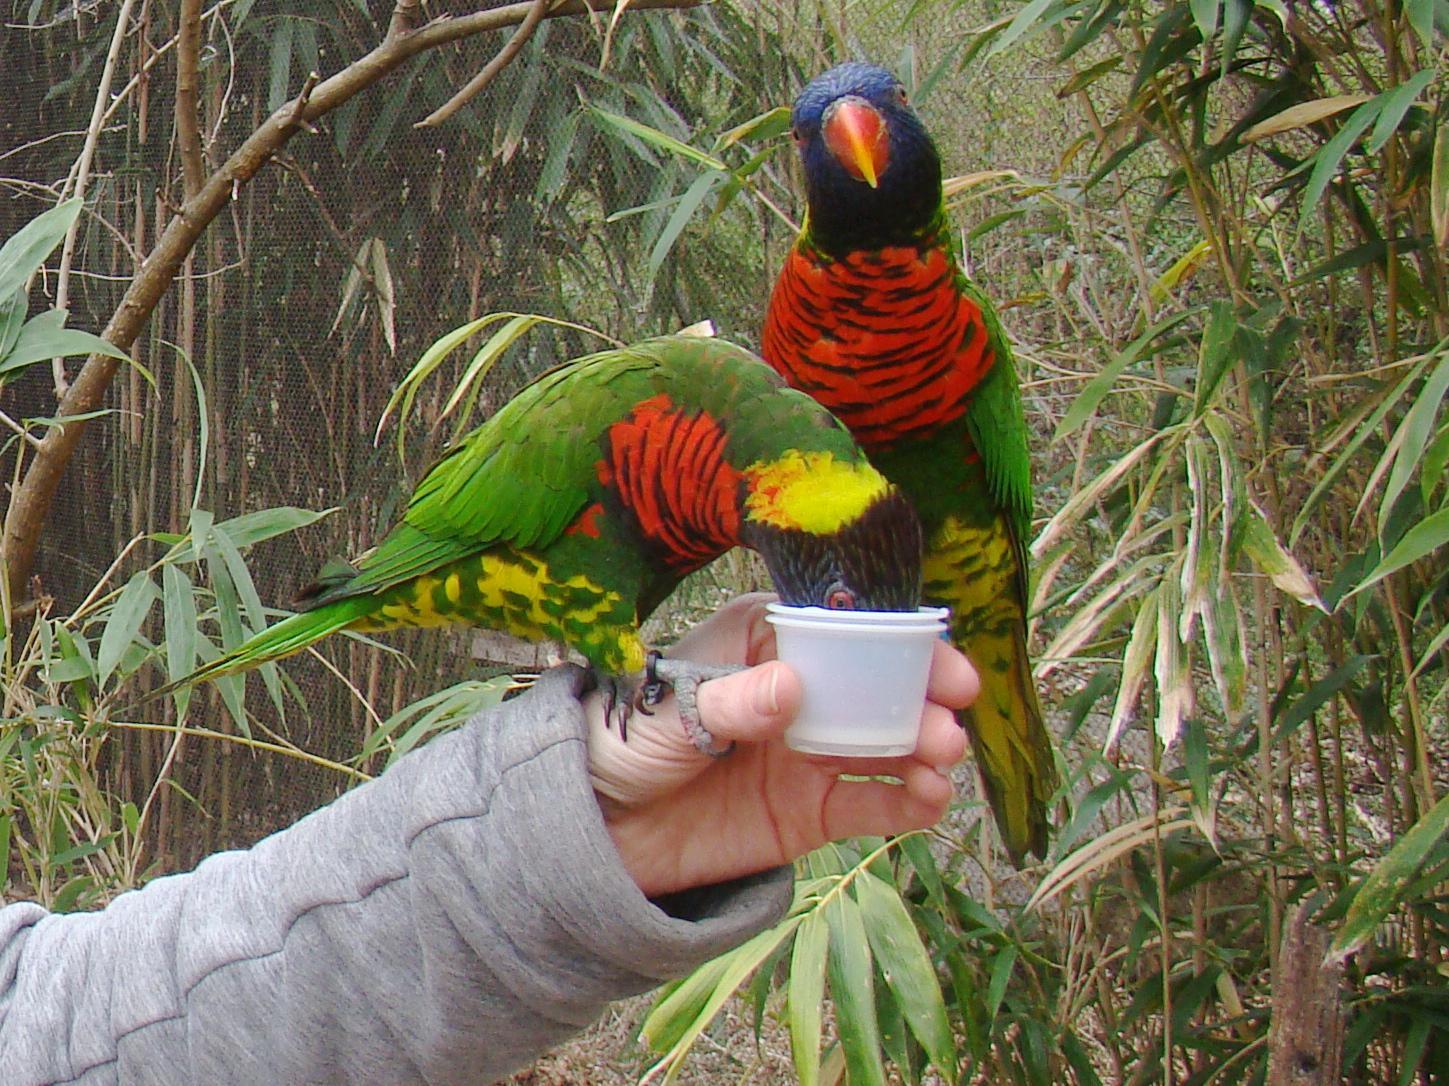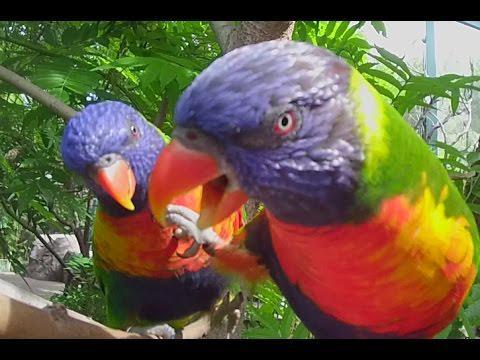The first image is the image on the left, the second image is the image on the right. Given the left and right images, does the statement "There are at least two colorful parrots in the right image." hold true? Answer yes or no. Yes. The first image is the image on the left, the second image is the image on the right. Examine the images to the left and right. Is the description "Each image contains a single bird, and at least one bird is pictured near a flower with tendril-like petals." accurate? Answer yes or no. No. 